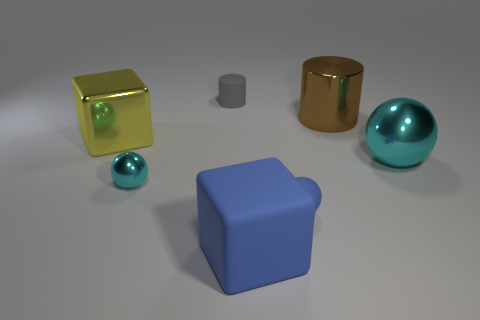Subtract all cyan blocks. Subtract all purple spheres. How many blocks are left? 2 Add 1 big cyan balls. How many objects exist? 8 Subtract all balls. How many objects are left? 4 Add 5 blue rubber blocks. How many blue rubber blocks are left? 6 Add 6 big blue objects. How many big blue objects exist? 7 Subtract 0 green cubes. How many objects are left? 7 Subtract all small brown matte blocks. Subtract all rubber spheres. How many objects are left? 6 